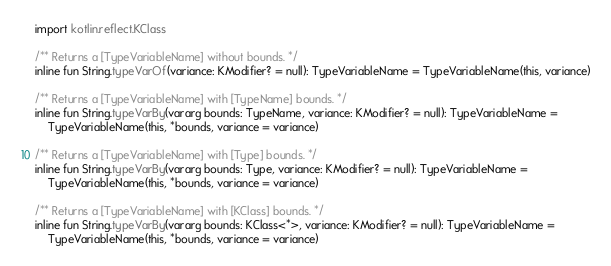<code> <loc_0><loc_0><loc_500><loc_500><_Kotlin_>import kotlin.reflect.KClass

/** Returns a [TypeVariableName] without bounds. */
inline fun String.typeVarOf(variance: KModifier? = null): TypeVariableName = TypeVariableName(this, variance)

/** Returns a [TypeVariableName] with [TypeName] bounds. */
inline fun String.typeVarBy(vararg bounds: TypeName, variance: KModifier? = null): TypeVariableName =
    TypeVariableName(this, *bounds, variance = variance)

/** Returns a [TypeVariableName] with [Type] bounds. */
inline fun String.typeVarBy(vararg bounds: Type, variance: KModifier? = null): TypeVariableName =
    TypeVariableName(this, *bounds, variance = variance)

/** Returns a [TypeVariableName] with [KClass] bounds. */
inline fun String.typeVarBy(vararg bounds: KClass<*>, variance: KModifier? = null): TypeVariableName =
    TypeVariableName(this, *bounds, variance = variance)
</code> 